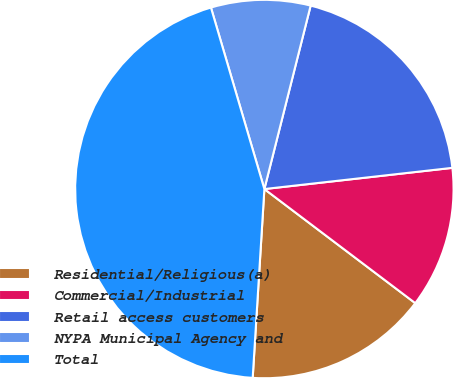Convert chart. <chart><loc_0><loc_0><loc_500><loc_500><pie_chart><fcel>Residential/Religious(a)<fcel>Commercial/Industrial<fcel>Retail access customers<fcel>NYPA Municipal Agency and<fcel>Total<nl><fcel>15.68%<fcel>12.09%<fcel>19.28%<fcel>8.49%<fcel>44.46%<nl></chart> 